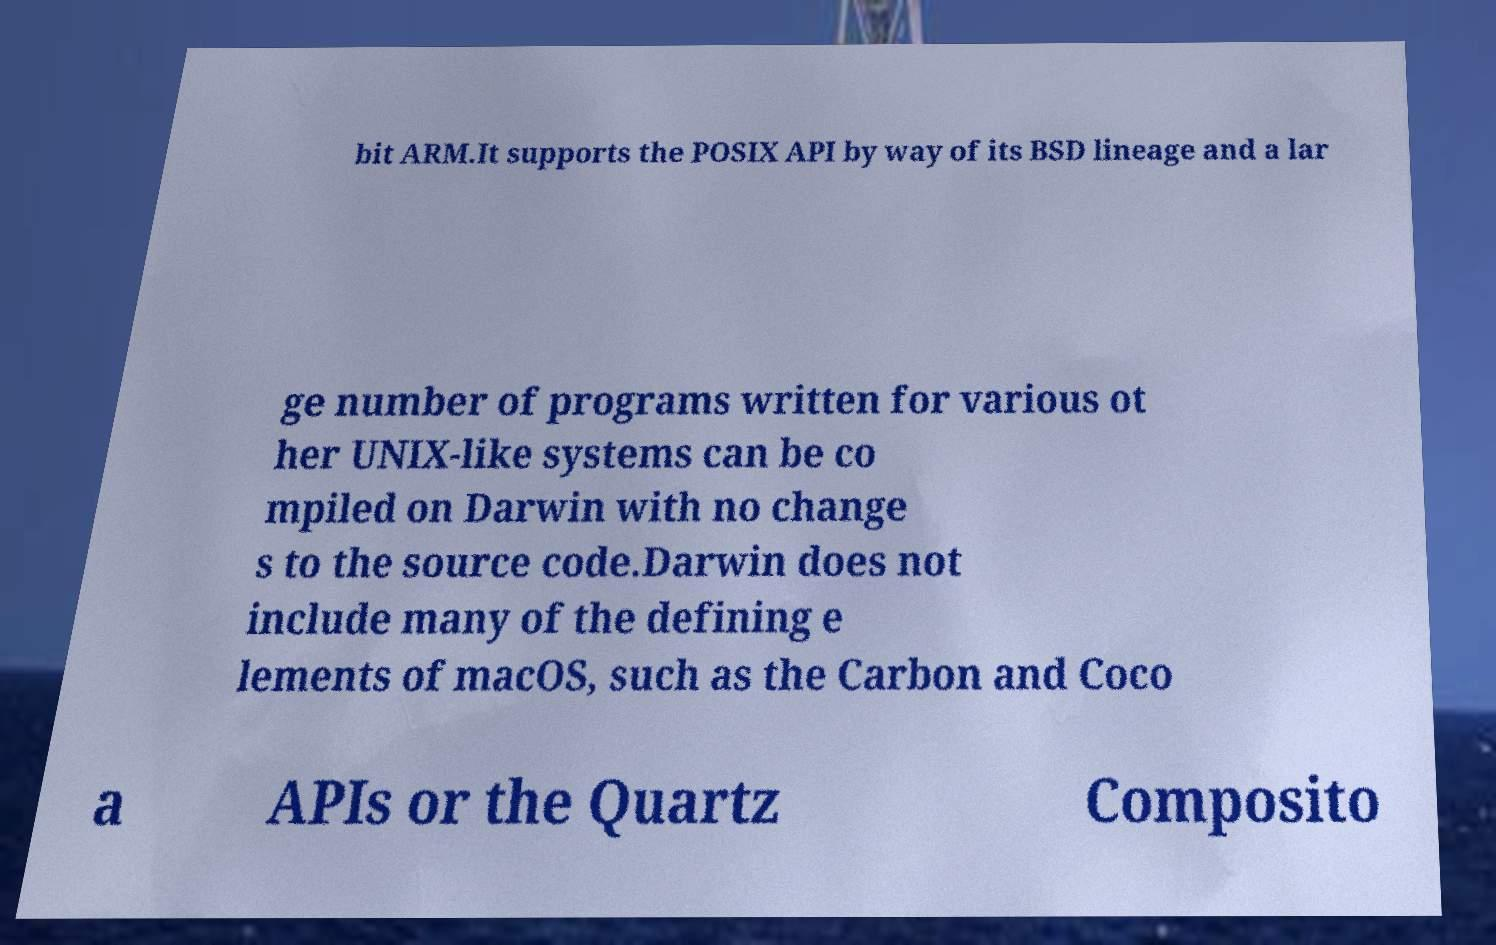There's text embedded in this image that I need extracted. Can you transcribe it verbatim? bit ARM.It supports the POSIX API by way of its BSD lineage and a lar ge number of programs written for various ot her UNIX-like systems can be co mpiled on Darwin with no change s to the source code.Darwin does not include many of the defining e lements of macOS, such as the Carbon and Coco a APIs or the Quartz Composito 